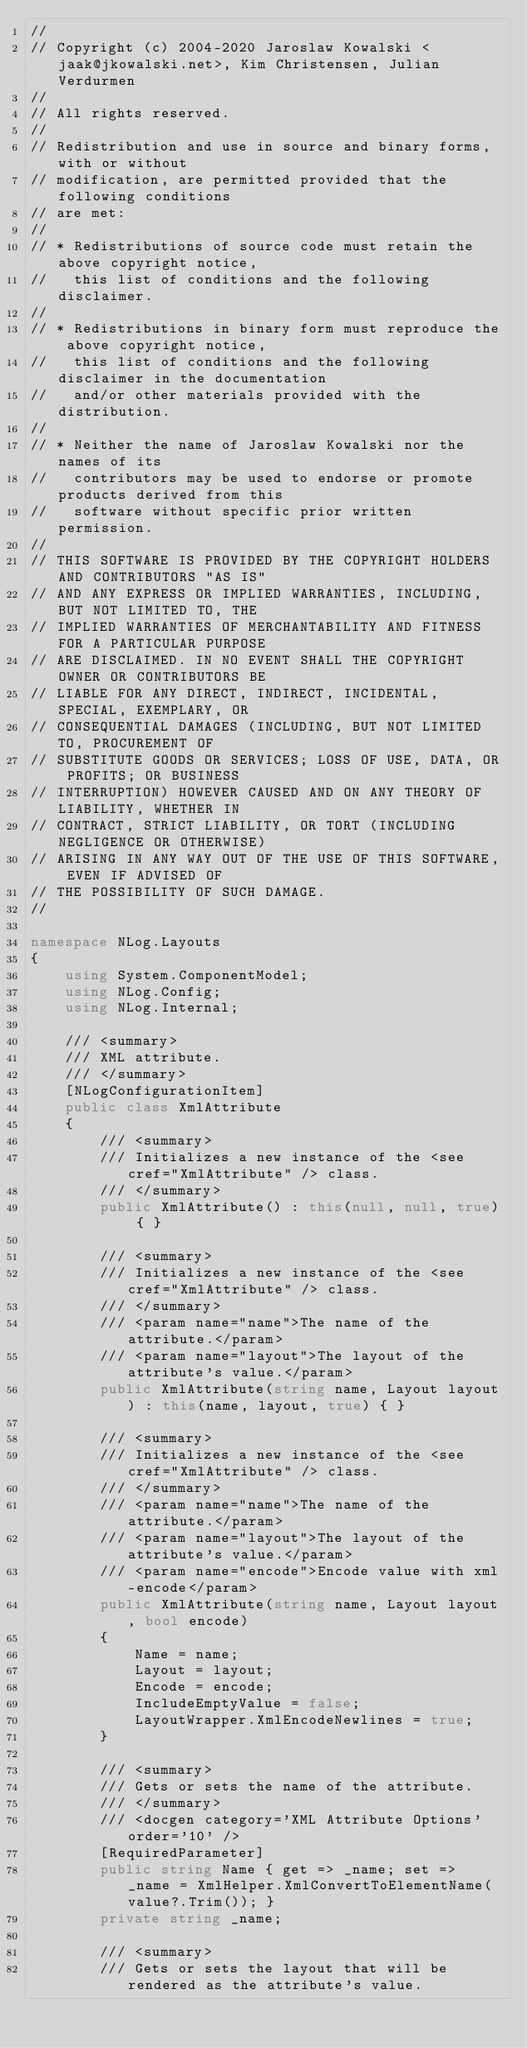Convert code to text. <code><loc_0><loc_0><loc_500><loc_500><_C#_>// 
// Copyright (c) 2004-2020 Jaroslaw Kowalski <jaak@jkowalski.net>, Kim Christensen, Julian Verdurmen
// 
// All rights reserved.
// 
// Redistribution and use in source and binary forms, with or without 
// modification, are permitted provided that the following conditions 
// are met:
// 
// * Redistributions of source code must retain the above copyright notice, 
//   this list of conditions and the following disclaimer. 
// 
// * Redistributions in binary form must reproduce the above copyright notice,
//   this list of conditions and the following disclaimer in the documentation
//   and/or other materials provided with the distribution. 
// 
// * Neither the name of Jaroslaw Kowalski nor the names of its 
//   contributors may be used to endorse or promote products derived from this
//   software without specific prior written permission. 
// 
// THIS SOFTWARE IS PROVIDED BY THE COPYRIGHT HOLDERS AND CONTRIBUTORS "AS IS"
// AND ANY EXPRESS OR IMPLIED WARRANTIES, INCLUDING, BUT NOT LIMITED TO, THE 
// IMPLIED WARRANTIES OF MERCHANTABILITY AND FITNESS FOR A PARTICULAR PURPOSE 
// ARE DISCLAIMED. IN NO EVENT SHALL THE COPYRIGHT OWNER OR CONTRIBUTORS BE 
// LIABLE FOR ANY DIRECT, INDIRECT, INCIDENTAL, SPECIAL, EXEMPLARY, OR 
// CONSEQUENTIAL DAMAGES (INCLUDING, BUT NOT LIMITED TO, PROCUREMENT OF
// SUBSTITUTE GOODS OR SERVICES; LOSS OF USE, DATA, OR PROFITS; OR BUSINESS 
// INTERRUPTION) HOWEVER CAUSED AND ON ANY THEORY OF LIABILITY, WHETHER IN 
// CONTRACT, STRICT LIABILITY, OR TORT (INCLUDING NEGLIGENCE OR OTHERWISE) 
// ARISING IN ANY WAY OUT OF THE USE OF THIS SOFTWARE, EVEN IF ADVISED OF 
// THE POSSIBILITY OF SUCH DAMAGE.
// 

namespace NLog.Layouts
{
    using System.ComponentModel;
    using NLog.Config;
    using NLog.Internal;

    /// <summary>
    /// XML attribute.
    /// </summary>
    [NLogConfigurationItem]
    public class XmlAttribute
    {
        /// <summary>
        /// Initializes a new instance of the <see cref="XmlAttribute" /> class.
        /// </summary>
        public XmlAttribute() : this(null, null, true) { }

        /// <summary>
        /// Initializes a new instance of the <see cref="XmlAttribute" /> class.
        /// </summary>
        /// <param name="name">The name of the attribute.</param>
        /// <param name="layout">The layout of the attribute's value.</param>
        public XmlAttribute(string name, Layout layout) : this(name, layout, true) { }

        /// <summary>
        /// Initializes a new instance of the <see cref="XmlAttribute" /> class.
        /// </summary>
        /// <param name="name">The name of the attribute.</param>
        /// <param name="layout">The layout of the attribute's value.</param>
        /// <param name="encode">Encode value with xml-encode</param>
        public XmlAttribute(string name, Layout layout, bool encode)
        {
            Name = name;
            Layout = layout;
            Encode = encode;
            IncludeEmptyValue = false;
            LayoutWrapper.XmlEncodeNewlines = true;
        }

        /// <summary>
        /// Gets or sets the name of the attribute.
        /// </summary>
        /// <docgen category='XML Attribute Options' order='10' />
        [RequiredParameter]
        public string Name { get => _name; set => _name = XmlHelper.XmlConvertToElementName(value?.Trim()); }
        private string _name;

        /// <summary>
        /// Gets or sets the layout that will be rendered as the attribute's value.</code> 